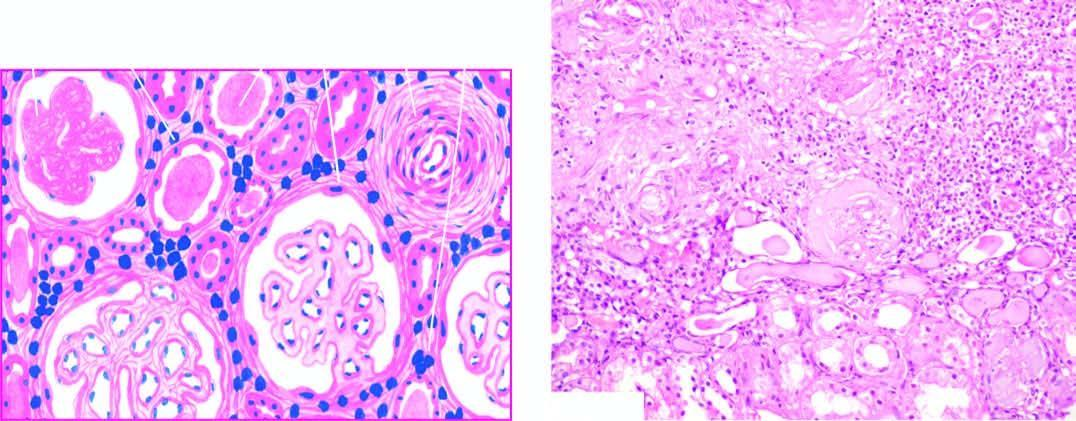re trophozoites of entamoeba histolytica included thick-walled?
Answer the question using a single word or phrase. No 